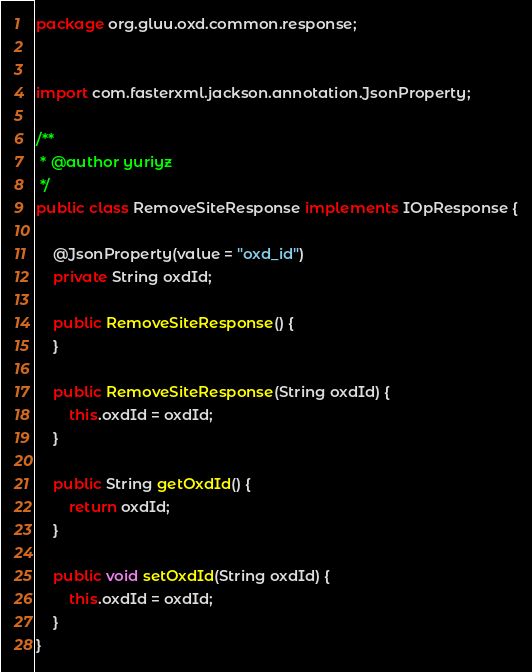Convert code to text. <code><loc_0><loc_0><loc_500><loc_500><_Java_>package org.gluu.oxd.common.response;


import com.fasterxml.jackson.annotation.JsonProperty;

/**
 * @author yuriyz
 */
public class RemoveSiteResponse implements IOpResponse {

    @JsonProperty(value = "oxd_id")
    private String oxdId;

    public RemoveSiteResponse() {
    }

    public RemoveSiteResponse(String oxdId) {
        this.oxdId = oxdId;
    }

    public String getOxdId() {
        return oxdId;
    }

    public void setOxdId(String oxdId) {
        this.oxdId = oxdId;
    }
}
</code> 